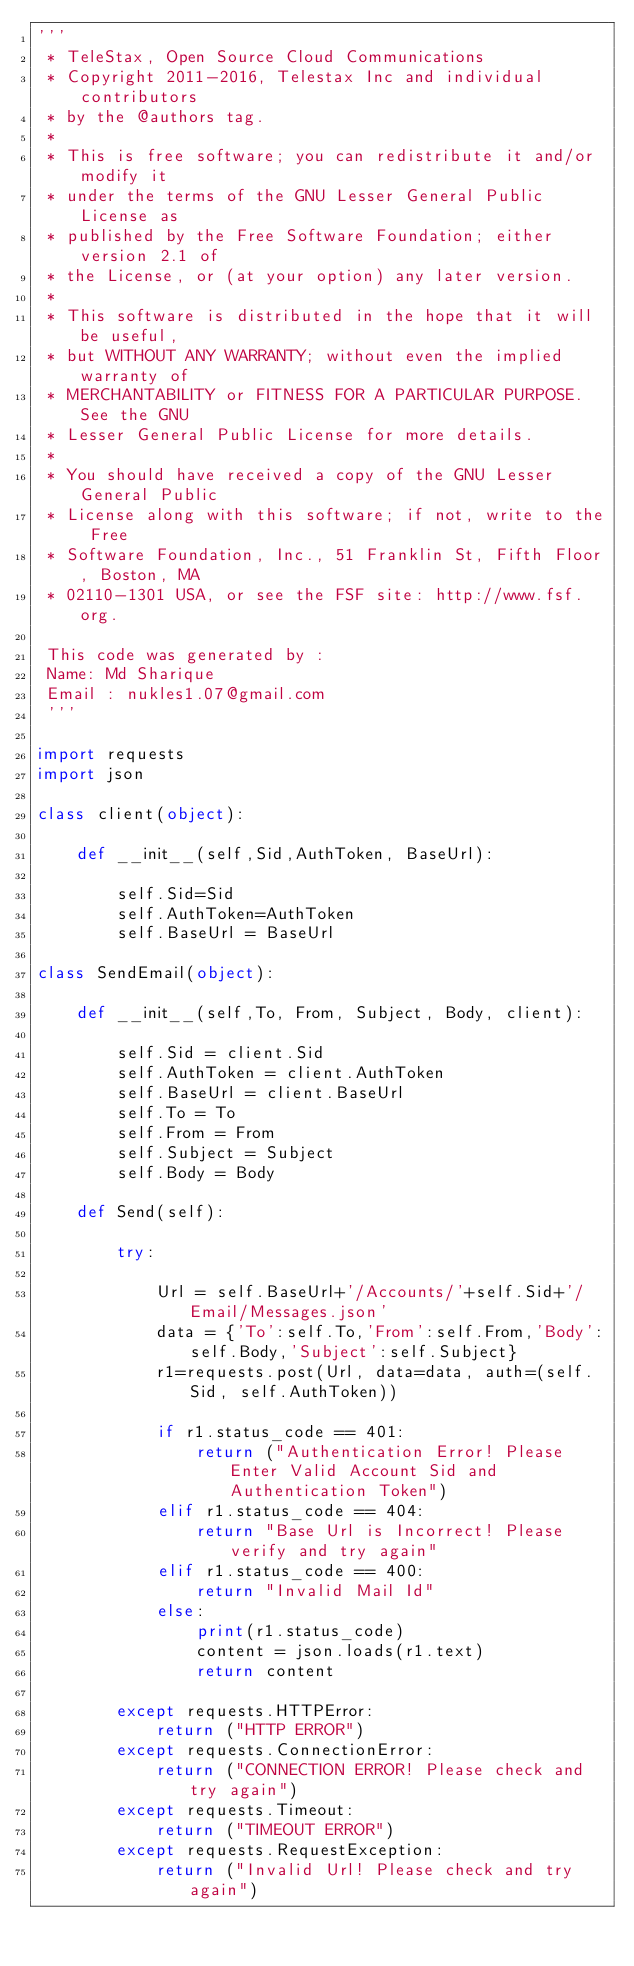Convert code to text. <code><loc_0><loc_0><loc_500><loc_500><_Python_>'''
 * TeleStax, Open Source Cloud Communications
 * Copyright 2011-2016, Telestax Inc and individual contributors
 * by the @authors tag.
 *
 * This is free software; you can redistribute it and/or modify it
 * under the terms of the GNU Lesser General Public License as
 * published by the Free Software Foundation; either version 2.1 of
 * the License, or (at your option) any later version.
 *
 * This software is distributed in the hope that it will be useful,
 * but WITHOUT ANY WARRANTY; without even the implied warranty of
 * MERCHANTABILITY or FITNESS FOR A PARTICULAR PURPOSE. See the GNU
 * Lesser General Public License for more details.
 *
 * You should have received a copy of the GNU Lesser General Public
 * License along with this software; if not, write to the Free
 * Software Foundation, Inc., 51 Franklin St, Fifth Floor, Boston, MA
 * 02110-1301 USA, or see the FSF site: http://www.fsf.org.
 
 This code was generated by :
 Name: Md Sharique
 Email : nukles1.07@gmail.com
 '''

import requests
import json

class client(object):

    def __init__(self,Sid,AuthToken, BaseUrl):

        self.Sid=Sid
        self.AuthToken=AuthToken
        self.BaseUrl = BaseUrl

class SendEmail(object):

    def __init__(self,To, From, Subject, Body, client):

        self.Sid = client.Sid
        self.AuthToken = client.AuthToken
        self.BaseUrl = client.BaseUrl
        self.To = To
        self.From = From
        self.Subject = Subject
        self.Body = Body

    def Send(self):

        try:

            Url = self.BaseUrl+'/Accounts/'+self.Sid+'/Email/Messages.json'
            data = {'To':self.To,'From':self.From,'Body':self.Body,'Subject':self.Subject}
            r1=requests.post(Url, data=data, auth=(self.Sid, self.AuthToken))

            if r1.status_code == 401:
                return ("Authentication Error! Please Enter Valid Account Sid and Authentication Token")
            elif r1.status_code == 404:
                return "Base Url is Incorrect! Please verify and try again"
            elif r1.status_code == 400:
                return "Invalid Mail Id"
            else:
                print(r1.status_code)
                content = json.loads(r1.text)
                return content

        except requests.HTTPError:
            return ("HTTP ERROR")
        except requests.ConnectionError:
            return ("CONNECTION ERROR! Please check and try again")
        except requests.Timeout:
            return ("TIMEOUT ERROR")
        except requests.RequestException:
            return ("Invalid Url! Please check and try again")
</code> 